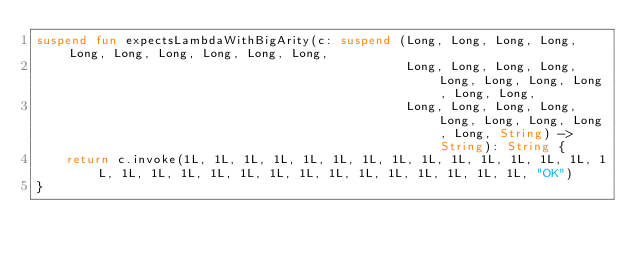Convert code to text. <code><loc_0><loc_0><loc_500><loc_500><_Kotlin_>suspend fun expectsLambdaWithBigArity(c: suspend (Long, Long, Long, Long, Long, Long, Long, Long, Long, Long,
                                                  Long, Long, Long, Long, Long, Long, Long, Long, Long, Long,
                                                  Long, Long, Long, Long, Long, Long, Long, Long, Long, String) -> String): String {
    return c.invoke(1L, 1L, 1L, 1L, 1L, 1L, 1L, 1L, 1L, 1L, 1L, 1L, 1L, 1L, 1L, 1L, 1L, 1L, 1L, 1L, 1L, 1L, 1L, 1L, 1L, 1L, 1L, 1L, 1L, "OK")
}
</code> 